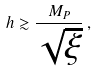<formula> <loc_0><loc_0><loc_500><loc_500>h \gtrsim \frac { M _ { P } } { \sqrt { \xi } } \, ,</formula> 